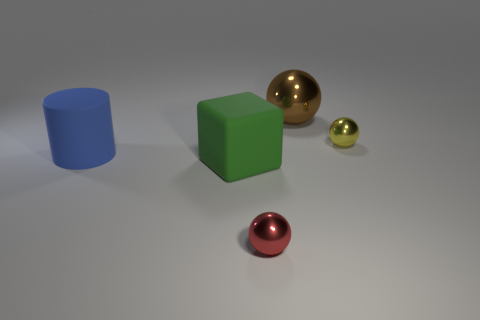Subtract all brown spheres. How many spheres are left? 2 Subtract all balls. How many objects are left? 2 Add 5 big green metal cylinders. How many objects exist? 10 Subtract 2 balls. How many balls are left? 1 Subtract all yellow balls. How many balls are left? 2 Subtract 0 gray cylinders. How many objects are left? 5 Subtract all gray spheres. Subtract all red cylinders. How many spheres are left? 3 Subtract all red cylinders. How many brown spheres are left? 1 Subtract all big brown balls. Subtract all small metallic spheres. How many objects are left? 2 Add 1 big green blocks. How many big green blocks are left? 2 